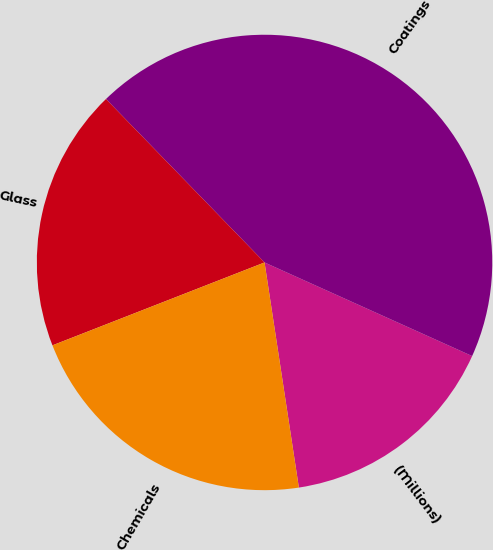<chart> <loc_0><loc_0><loc_500><loc_500><pie_chart><fcel>(Millions)<fcel>Coatings<fcel>Glass<fcel>Chemicals<nl><fcel>15.85%<fcel>44.0%<fcel>18.67%<fcel>21.48%<nl></chart> 